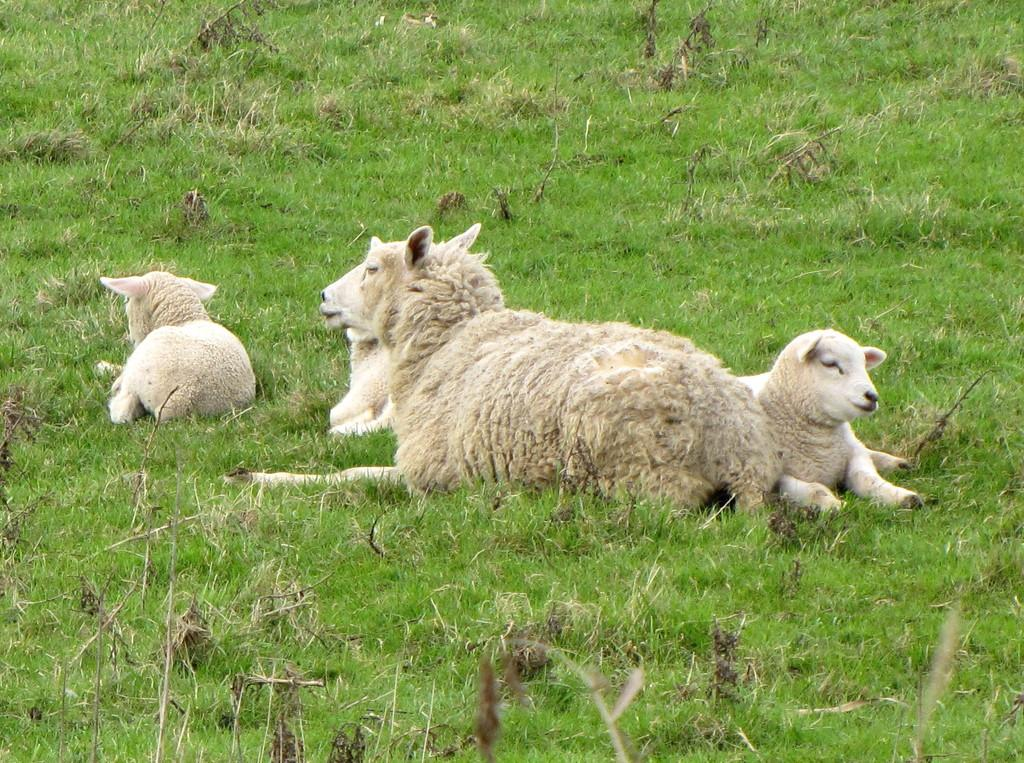What type of animals are present in the image? There are sheep in the image. Where are the sheep located? The sheep are on the grass. What type of mass is being held in the image? There is no mass present in the image; it features sheep on the grass. Is there any indication of war or conflict in the image? No, there is no indication of war or conflict in the image; it features sheep on the grass. 